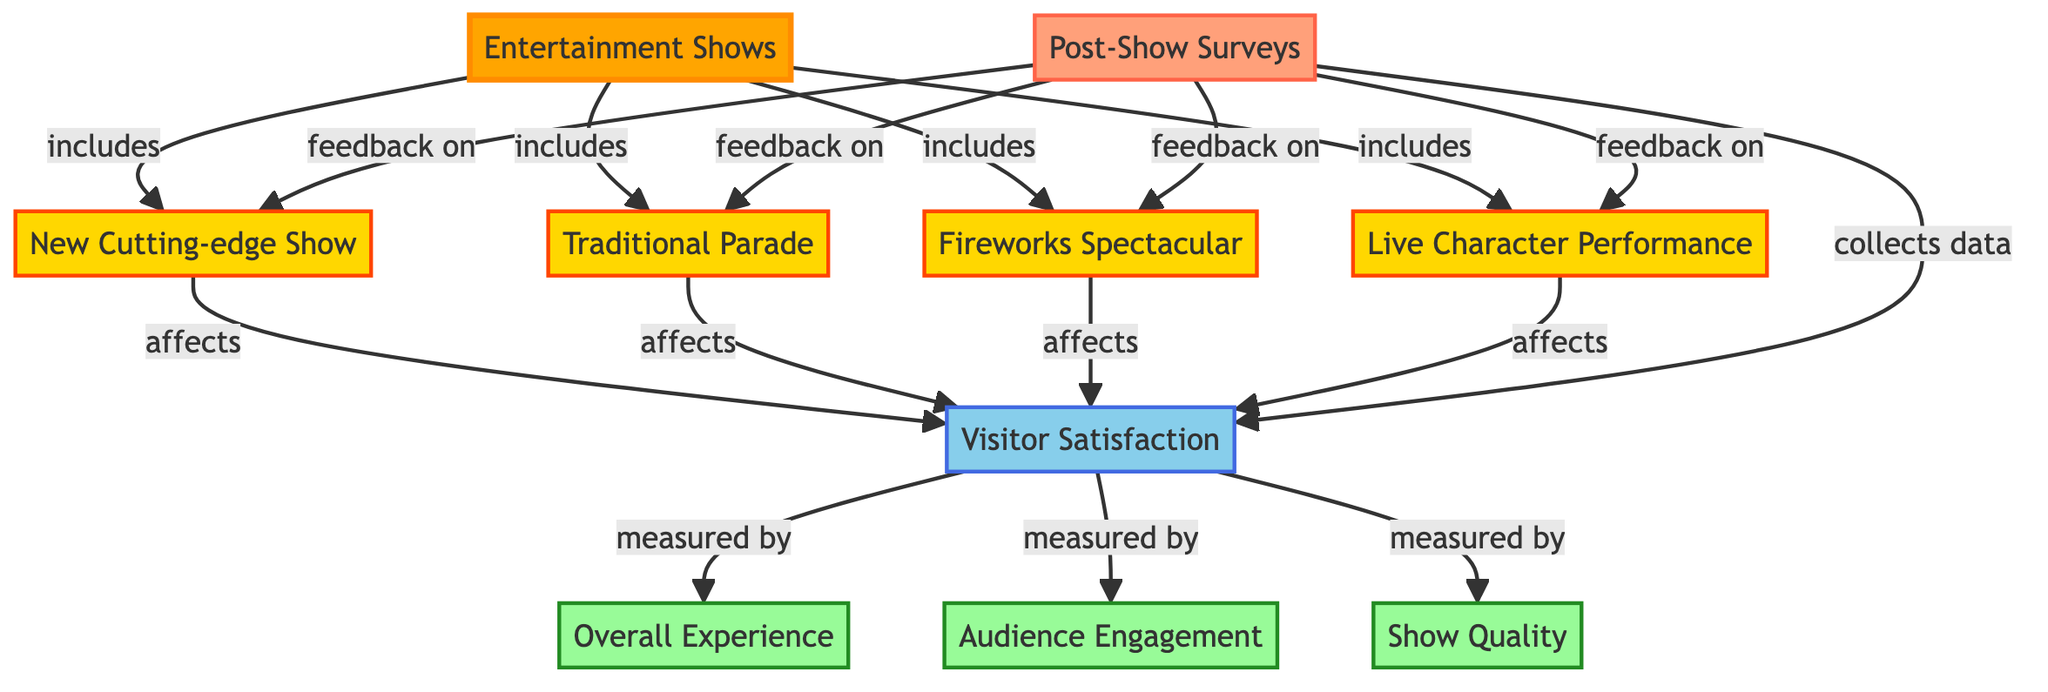What types of entertainment shows are included? The diagram specifies four types of entertainment shows: New Cutting-edge Show, Traditional Parade, Fireworks Spectacular, and Live Character Performance. These are all listed under the "Entertainment Shows" node, indicating they are part of the same category.
Answer: New Cutting-edge Show, Traditional Parade, Fireworks Spectacular, Live Character Performance How many measures are used to assess visitor satisfaction? The "Visitor Satisfaction" node connects to three measurements: Overall Experience, Audience Engagement, and Show Quality. This indicates that visitor satisfaction is assessed using three distinct measures.
Answer: 3 What node collects data on visitor satisfaction? The "Post-Show Surveys" node is linked to "Visitor Satisfaction," indicating that it is responsible for collecting data that reflects visitor satisfaction after the shows.
Answer: Post-Show Surveys Which entertainment show has feedback collected on it? The diagram shows that the "Post-Show Surveys" node provides feedback for all four entertainment shows, which implies all of them gather data through the surveys.
Answer: All shows How do visitor satisfaction scores relate to the entertainment shows? Each of the shows, including the New Cutting-edge Show, impacts Visitor Satisfaction directly, as shown by the arrows connecting each show to the "Visitor Satisfaction" node. This indicates that the quality of each show influences the overall satisfaction of visitors.
Answer: They affect visitor satisfaction Which measurement is NOT used to determine visitor satisfaction? The diagram lists three measurements for visitor satisfaction—Overall Experience, Audience Engagement, and Show Quality—indicating they are all accounted for. Therefore, any other measurement not mentioned in these three categories can be considered as not being used.
Answer: None (all mentioned are used) What type of relationship exists between entertainment shows and visitor satisfaction? The entertainment shows directly impact visitor satisfaction, as shown by the directed arrows towards the "Visitor Satisfaction" node from each of the entertainment shows. This illustrates a cause-and-effect relationship where shows that perform better might increase visitor satisfaction.
Answer: They affect visitor satisfaction How is audience engagement measured according to the diagram? Audience engagement is represented as one of the three measurements connected to the "Visitor Satisfaction" node. This implies that audience engagement is considered a factor that contributes to and is measured within visitor satisfaction assessments.
Answer: Measured by Visitor Satisfaction 